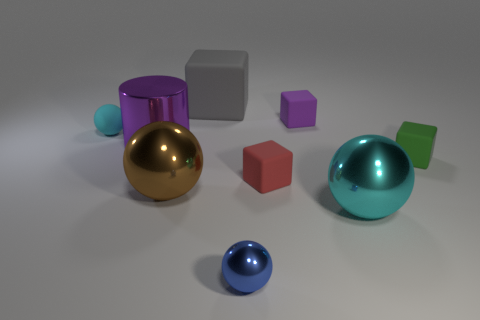Subtract 1 cubes. How many cubes are left? 3 Subtract all blocks. How many objects are left? 5 Add 1 tiny red things. How many tiny red things are left? 2 Add 1 tiny cylinders. How many tiny cylinders exist? 1 Subtract 2 cyan spheres. How many objects are left? 7 Subtract all tiny purple matte things. Subtract all big brown metallic balls. How many objects are left? 7 